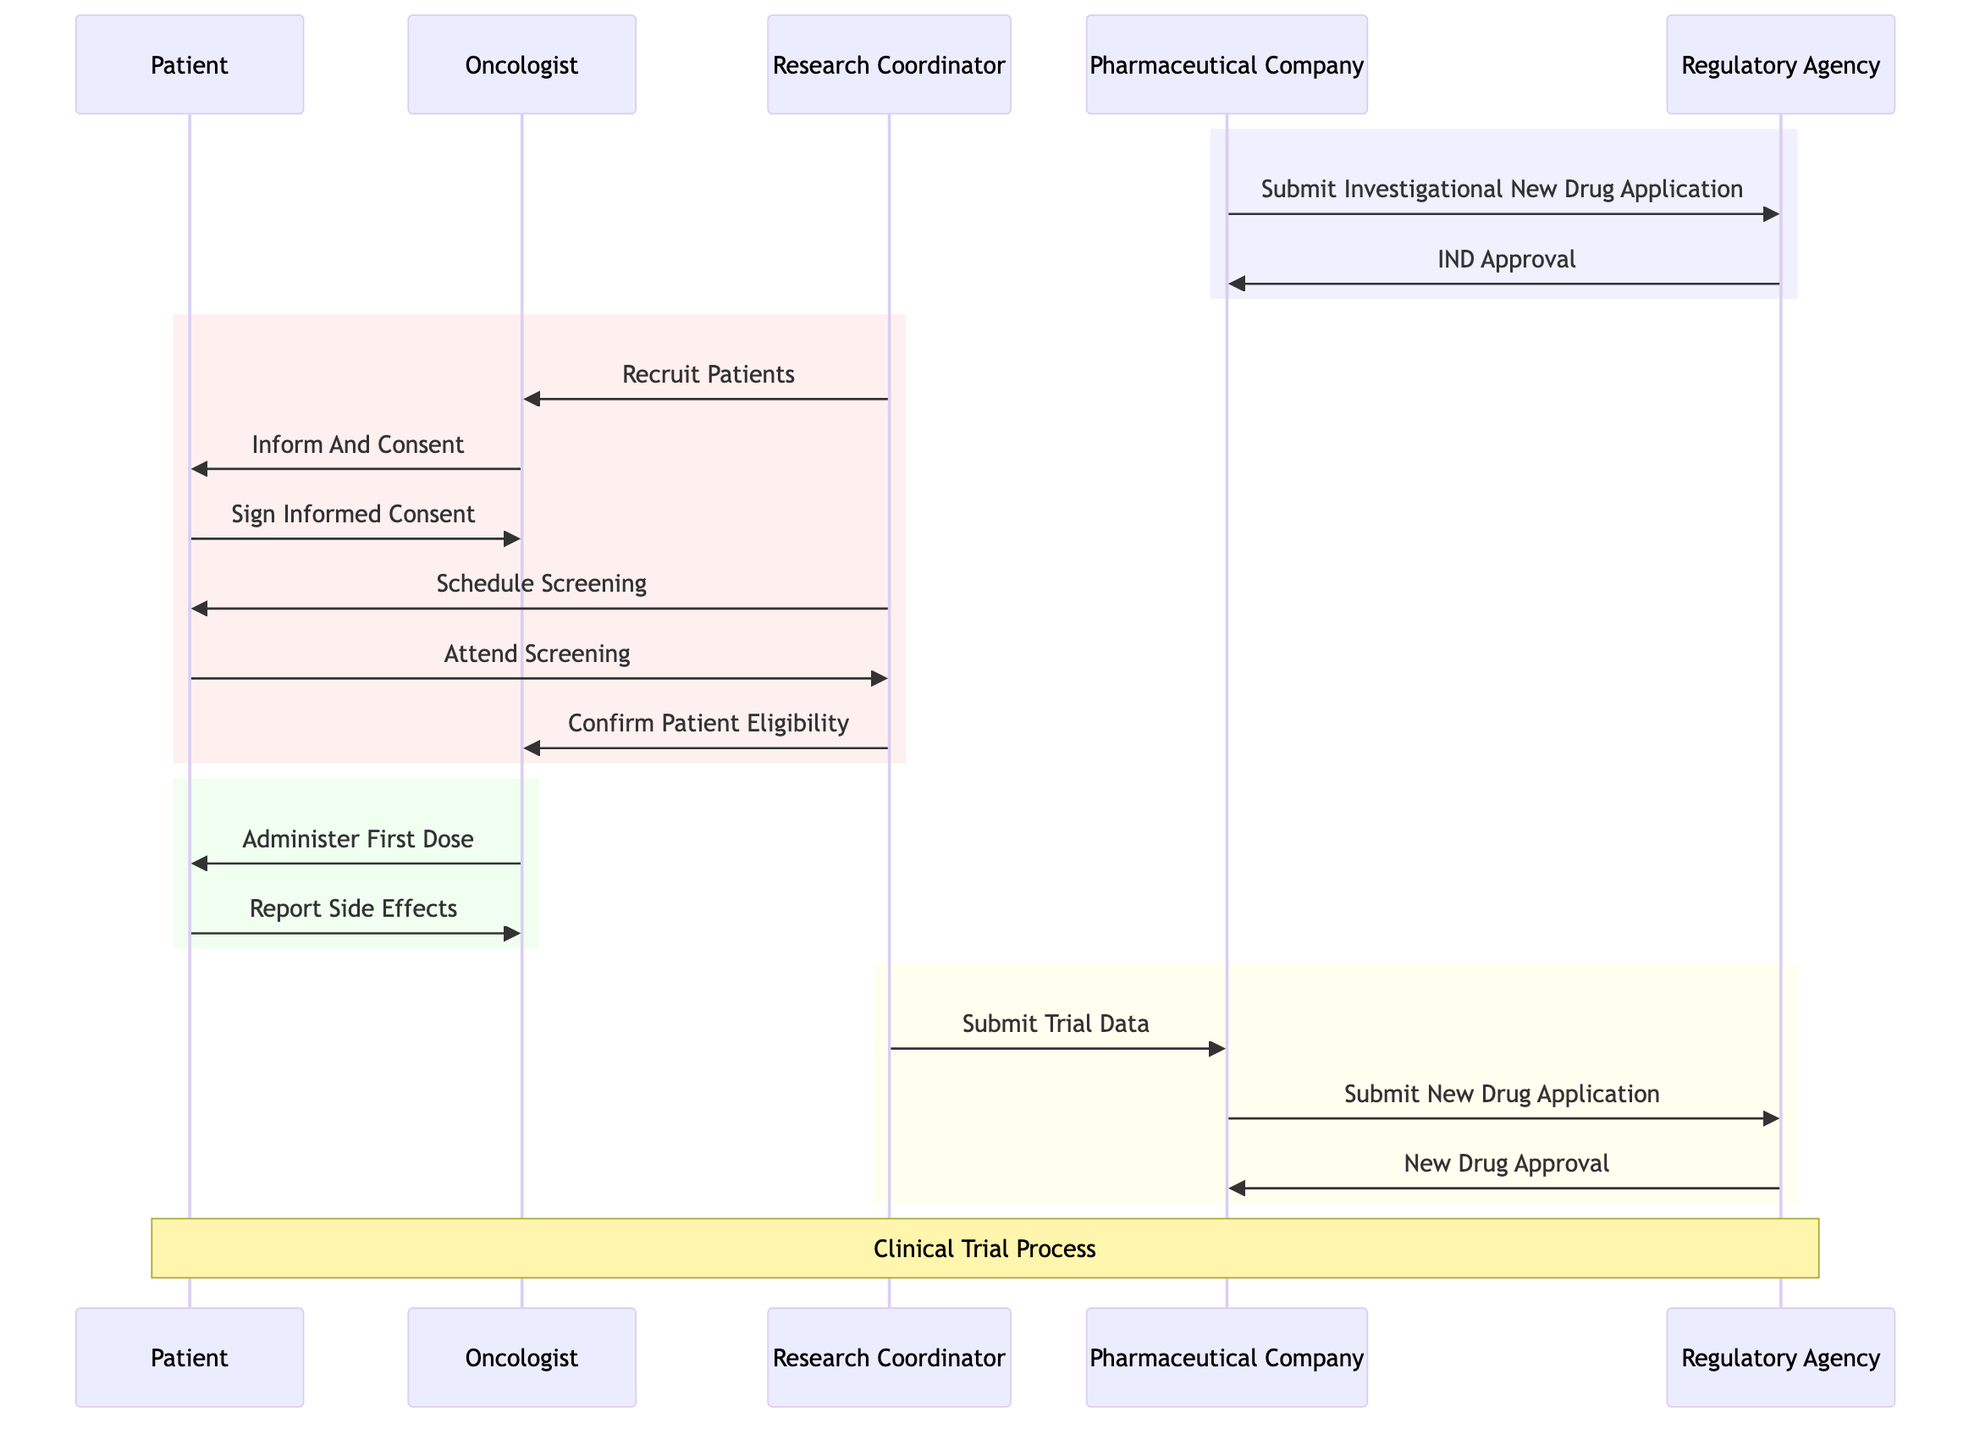What is the role of the Pharmaceutical Company? The Pharmaceutical Company is the entity developing the immunotherapy drug, as indicated by its label in the diagram.
Answer: Company developing the immunotherapy drug Who administers the first dose to the patient? The first dose is administered by the Oncologist, as shown in the sequence where the Oncologist communicates with the Patient for this action.
Answer: Oncologist How many participants are involved in the sequence? There are five participants listed in the sequence diagram: Patient, Oncologist, Research Coordinator, Pharmaceutical Company, and Regulatory Agency.
Answer: Five What is the first action taken in the clinical trial process? The first action taken is the submission of the Investigational New Drug Application by the Pharmaceutical Company to the Regulatory Agency, according to the order of messages in the diagram.
Answer: Submit Investigational New Drug Application What event occurs after a patient attends screening? Following the patient's attendance at the screening, the Research Coordinator confirms the patient's eligibility to proceed in the trial, which is the next action shown in the flow from the Patient to the Research Coordinator and then to the Oncologist.
Answer: Confirm Patient Eligibility What type of note is present in the diagram? A note is present that summarizes the entire process, indicating that the diagram represents the clinical trial process for the new cancer immunotherapy drug, as shown by the note placement over the Patient and Regulatory Agency.
Answer: Clinical Trial Process How does the Regulatory Agency respond to the New Drug Application? The Regulatory Agency's response to the New Drug Application is the approval of the new drug, which is a key message back to the Pharmaceutical Company at the end of the trial process.
Answer: New Drug Approval What is the purpose of the message "Sign Informed Consent"? The purpose of the "Sign Informed Consent" message is to indicate that the Patient agrees to participate in the clinical trial after being informed about its details by the Oncologist, illustrated in the interaction between these two participants.
Answer: Agree to participate 